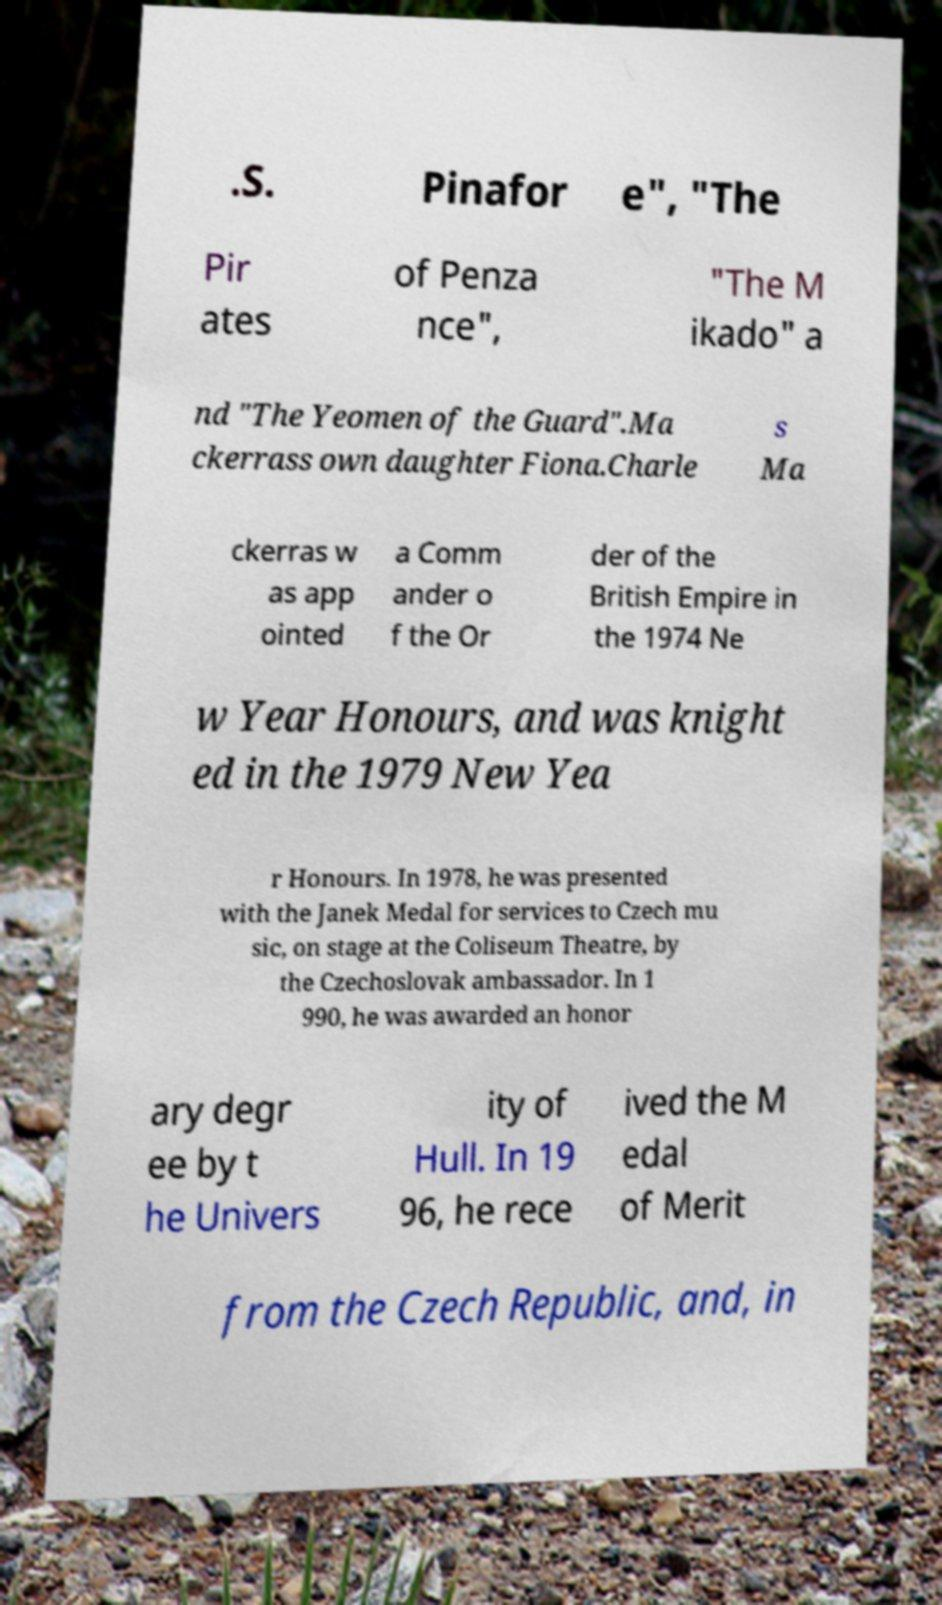Could you assist in decoding the text presented in this image and type it out clearly? .S. Pinafor e", "The Pir ates of Penza nce", "The M ikado" a nd "The Yeomen of the Guard".Ma ckerrass own daughter Fiona.Charle s Ma ckerras w as app ointed a Comm ander o f the Or der of the British Empire in the 1974 Ne w Year Honours, and was knight ed in the 1979 New Yea r Honours. In 1978, he was presented with the Janek Medal for services to Czech mu sic, on stage at the Coliseum Theatre, by the Czechoslovak ambassador. In 1 990, he was awarded an honor ary degr ee by t he Univers ity of Hull. In 19 96, he rece ived the M edal of Merit from the Czech Republic, and, in 